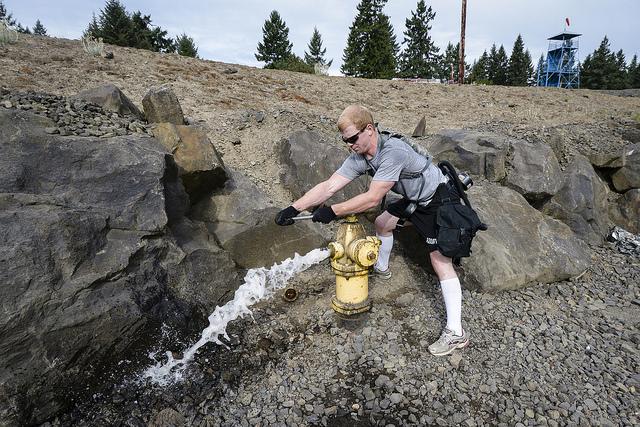Where is the man's right leg?
Answer briefly. On rock. What's he doing?
Concise answer only. Opening hydrant. Is the man wearing socks?
Give a very brief answer. Yes. 